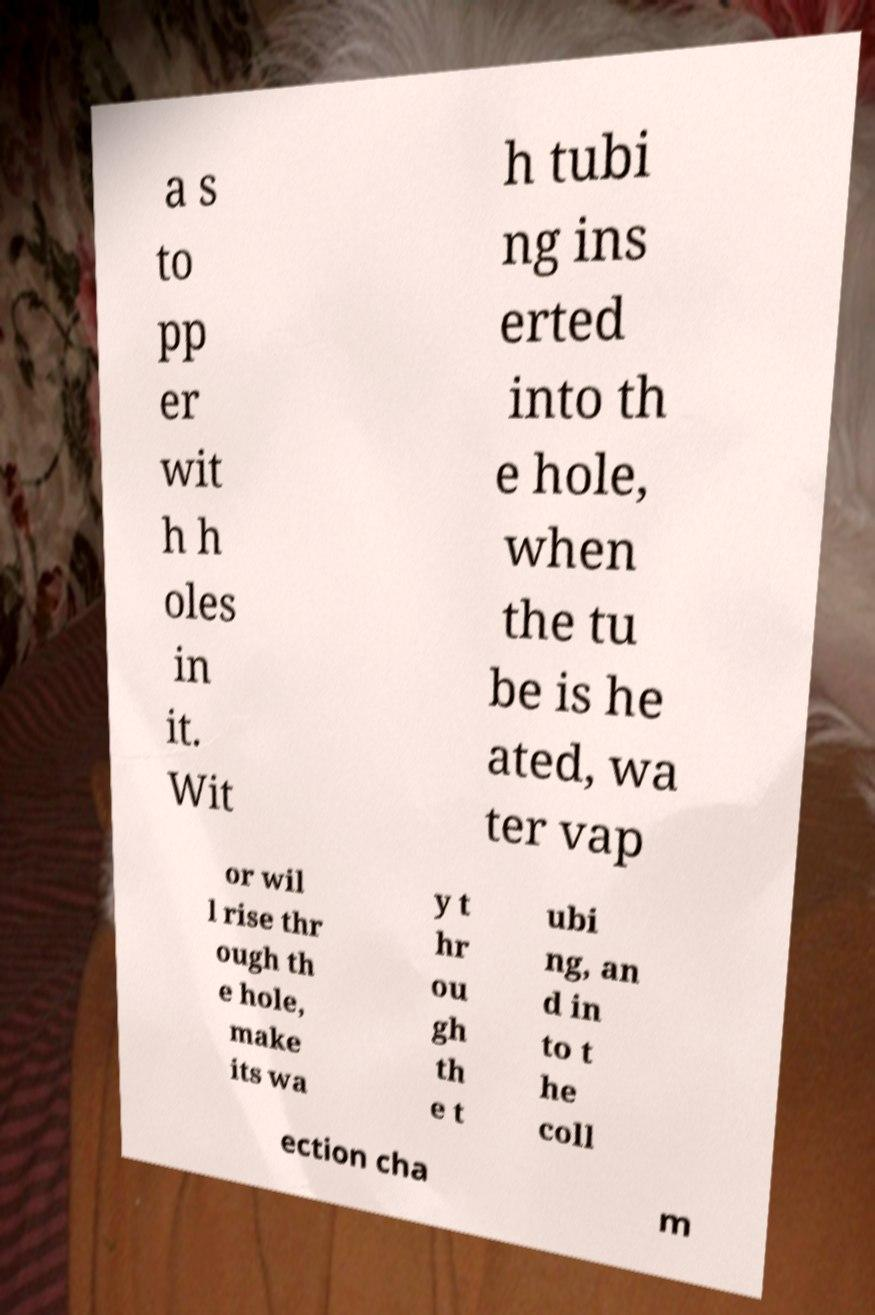Could you assist in decoding the text presented in this image and type it out clearly? a s to pp er wit h h oles in it. Wit h tubi ng ins erted into th e hole, when the tu be is he ated, wa ter vap or wil l rise thr ough th e hole, make its wa y t hr ou gh th e t ubi ng, an d in to t he coll ection cha m 